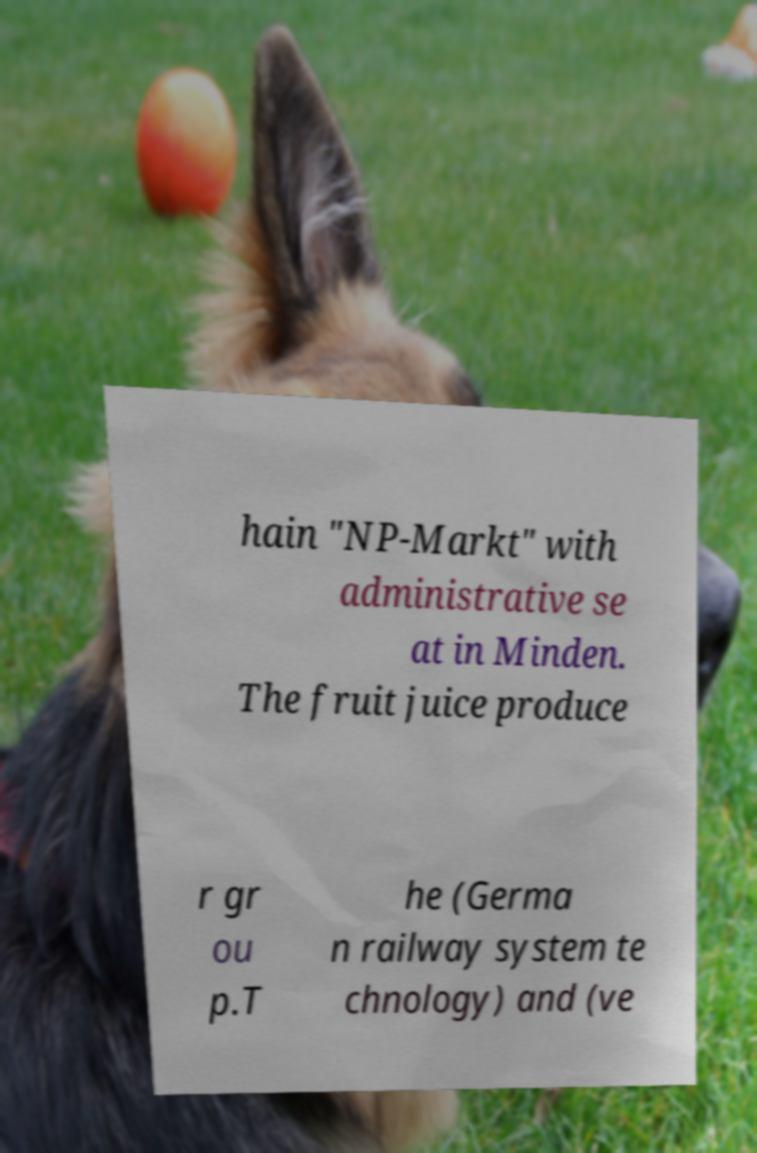What messages or text are displayed in this image? I need them in a readable, typed format. hain "NP-Markt" with administrative se at in Minden. The fruit juice produce r gr ou p.T he (Germa n railway system te chnology) and (ve 